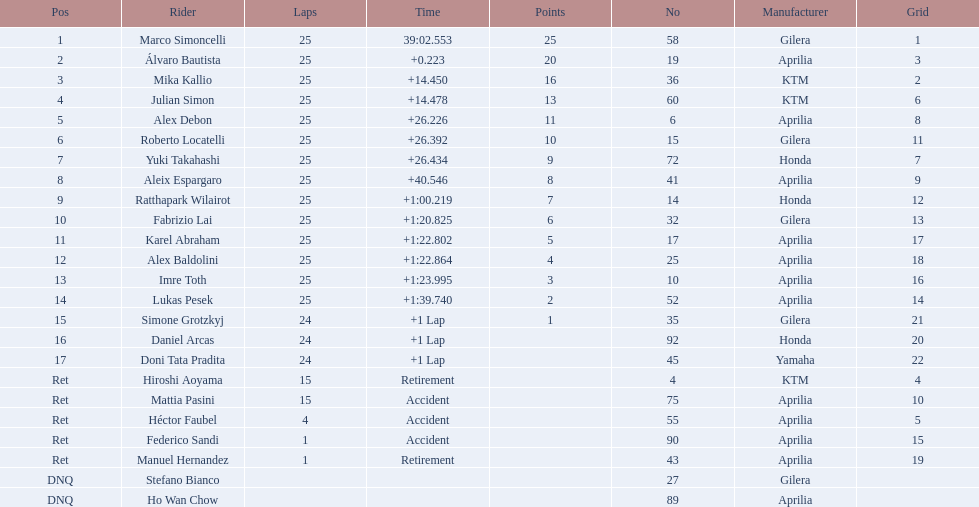Who are all the riders? Marco Simoncelli, Álvaro Bautista, Mika Kallio, Julian Simon, Alex Debon, Roberto Locatelli, Yuki Takahashi, Aleix Espargaro, Ratthapark Wilairot, Fabrizio Lai, Karel Abraham, Alex Baldolini, Imre Toth, Lukas Pesek, Simone Grotzkyj, Daniel Arcas, Doni Tata Pradita, Hiroshi Aoyama, Mattia Pasini, Héctor Faubel, Federico Sandi, Manuel Hernandez, Stefano Bianco, Ho Wan Chow. Which held rank 1? Marco Simoncelli. 